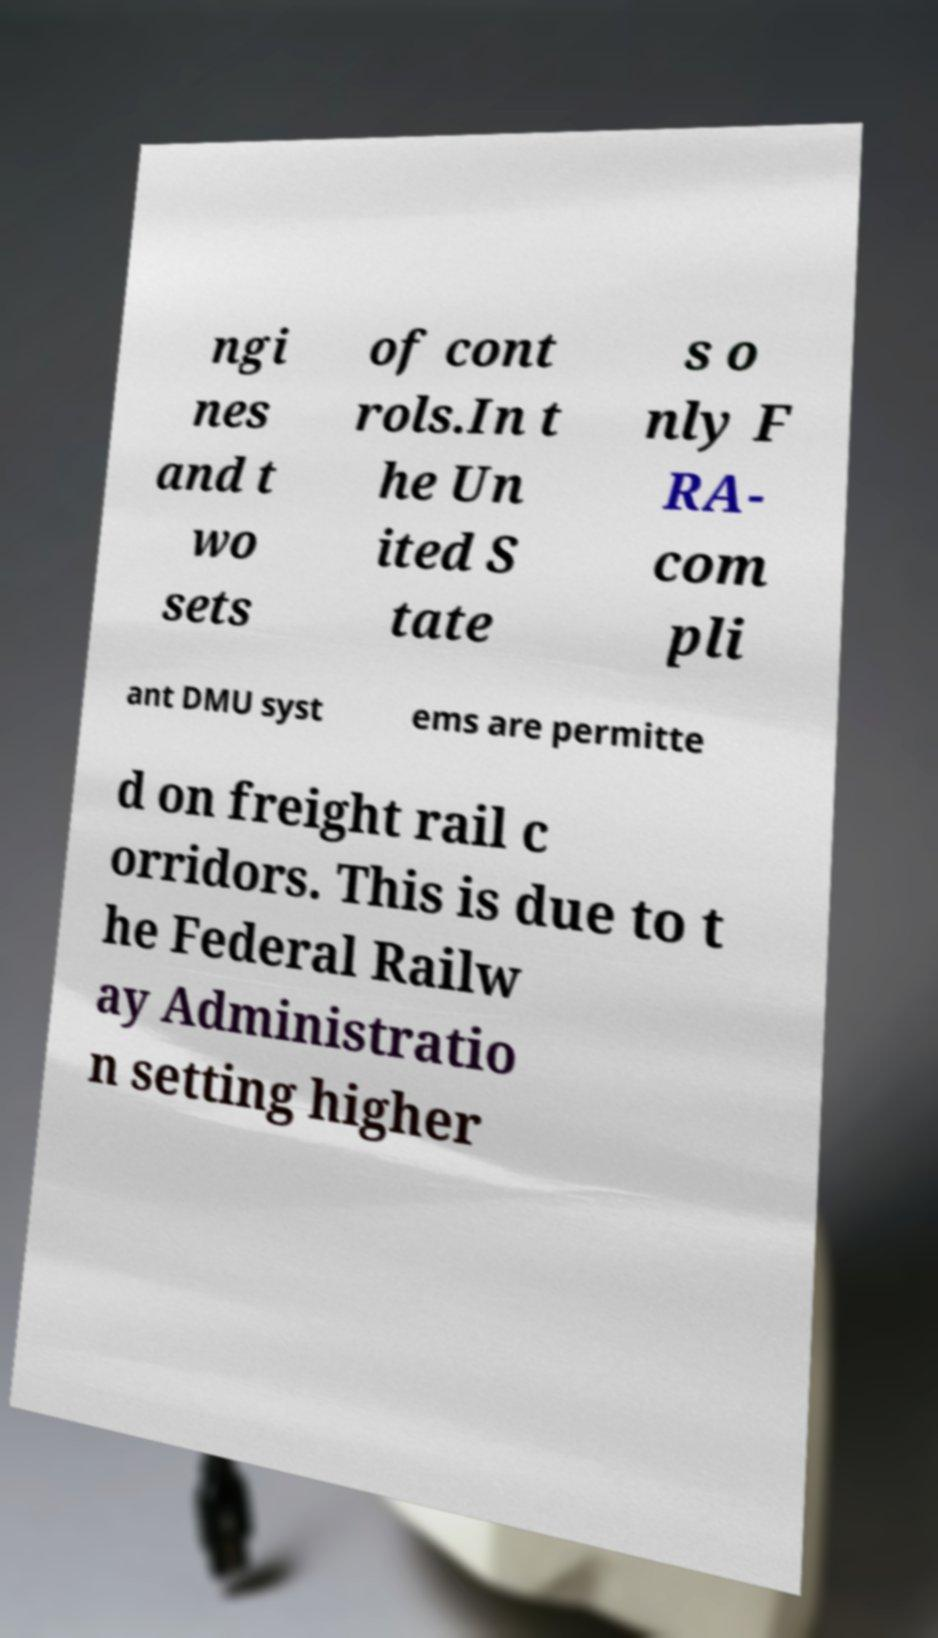Could you extract and type out the text from this image? ngi nes and t wo sets of cont rols.In t he Un ited S tate s o nly F RA- com pli ant DMU syst ems are permitte d on freight rail c orridors. This is due to t he Federal Railw ay Administratio n setting higher 